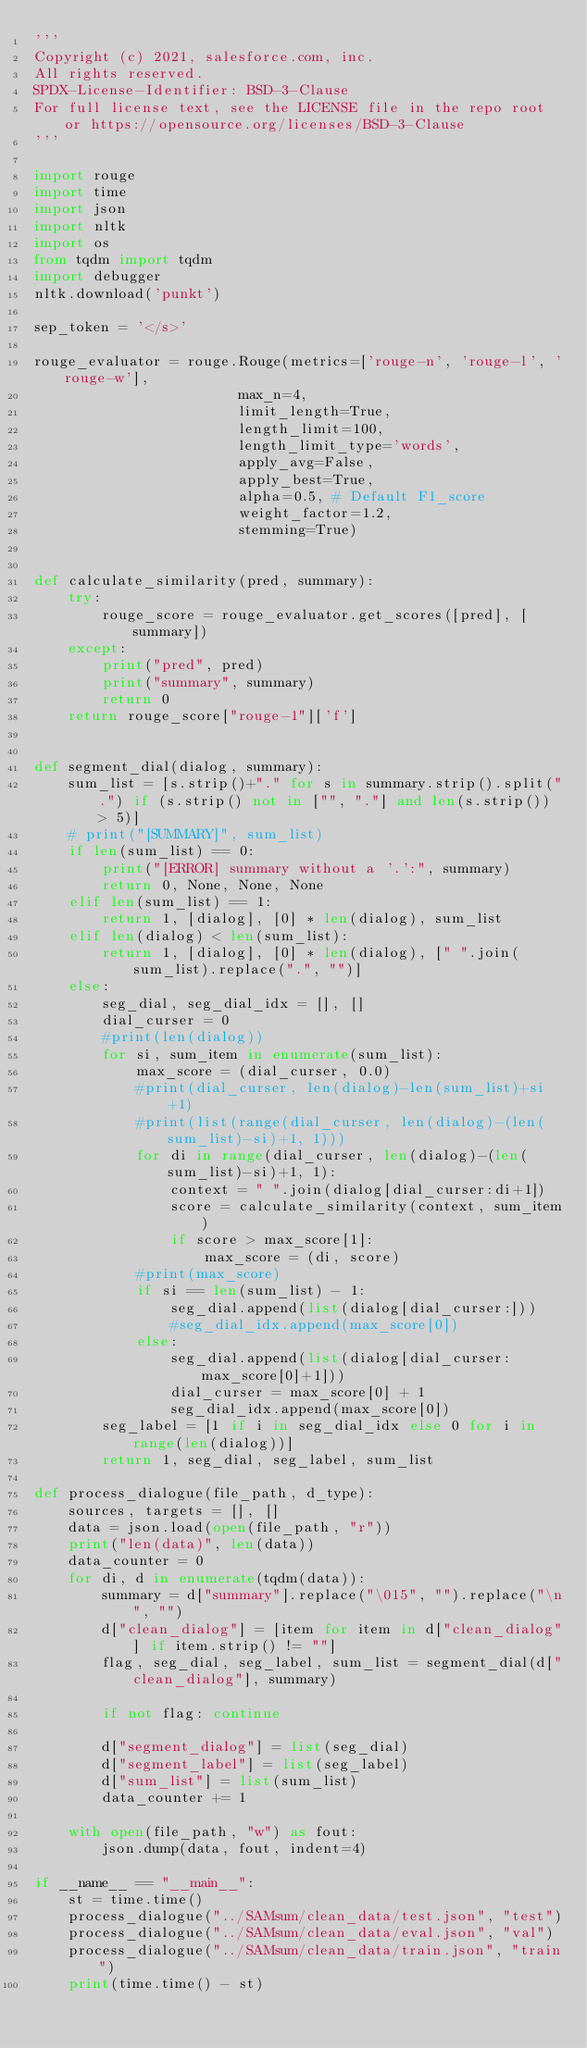<code> <loc_0><loc_0><loc_500><loc_500><_Python_>'''
Copyright (c) 2021, salesforce.com, inc.
All rights reserved.
SPDX-License-Identifier: BSD-3-Clause
For full license text, see the LICENSE file in the repo root or https://opensource.org/licenses/BSD-3-Clause
'''

import rouge
import time
import json
import nltk
import os
from tqdm import tqdm
import debugger
nltk.download('punkt')

sep_token = '</s>'
    
rouge_evaluator = rouge.Rouge(metrics=['rouge-n', 'rouge-l', 'rouge-w'],
                        max_n=4,
                        limit_length=True,
                        length_limit=100,
                        length_limit_type='words',
                        apply_avg=False,
                        apply_best=True,
                        alpha=0.5, # Default F1_score
                        weight_factor=1.2,
                        stemming=True)


def calculate_similarity(pred, summary):
    try:
        rouge_score = rouge_evaluator.get_scores([pred], [summary])
    except:
        print("pred", pred)
        print("summary", summary)
        return 0
    return rouge_score["rouge-1"]['f']


def segment_dial(dialog, summary):
    sum_list = [s.strip()+"." for s in summary.strip().split(".") if (s.strip() not in ["", "."] and len(s.strip()) > 5)]
    # print("[SUMMARY]", sum_list)
    if len(sum_list) == 0:
        print("[ERROR] summary without a '.':", summary)
        return 0, None, None, None
    elif len(sum_list) == 1:
        return 1, [dialog], [0] * len(dialog), sum_list
    elif len(dialog) < len(sum_list):
        return 1, [dialog], [0] * len(dialog), [" ".join(sum_list).replace(".", "")]
    else:
        seg_dial, seg_dial_idx = [], []
        dial_curser = 0
        #print(len(dialog))
        for si, sum_item in enumerate(sum_list):
            max_score = (dial_curser, 0.0) 
            #print(dial_curser, len(dialog)-len(sum_list)+si+1)
            #print(list(range(dial_curser, len(dialog)-(len(sum_list)-si)+1, 1)))
            for di in range(dial_curser, len(dialog)-(len(sum_list)-si)+1, 1):
                context = " ".join(dialog[dial_curser:di+1])
                score = calculate_similarity(context, sum_item)
                if score > max_score[1]:
                    max_score = (di, score)
            #print(max_score)
            if si == len(sum_list) - 1:
                seg_dial.append(list(dialog[dial_curser:]))
                #seg_dial_idx.append(max_score[0])
            else:
                seg_dial.append(list(dialog[dial_curser:max_score[0]+1])) 
                dial_curser = max_score[0] + 1
                seg_dial_idx.append(max_score[0])
        seg_label = [1 if i in seg_dial_idx else 0 for i in range(len(dialog))]
        return 1, seg_dial, seg_label, sum_list

def process_dialogue(file_path, d_type):
    sources, targets = [], []
    data = json.load(open(file_path, "r"))
    print("len(data)", len(data))
    data_counter = 0
    for di, d in enumerate(tqdm(data)):
        summary = d["summary"].replace("\015", "").replace("\n", "")
        d["clean_dialog"] = [item for item in d["clean_dialog"] if item.strip() != ""]
        flag, seg_dial, seg_label, sum_list = segment_dial(d["clean_dialog"], summary)
        
        if not flag: continue
        
        d["segment_dialog"] = list(seg_dial)
        d["segment_label"] = list(seg_label)
        d["sum_list"] = list(sum_list)
        data_counter += 1
        
    with open(file_path, "w") as fout:
        json.dump(data, fout, indent=4)

if __name__ == "__main__":
    st = time.time()
    process_dialogue("../SAMsum/clean_data/test.json", "test")
    process_dialogue("../SAMsum/clean_data/eval.json", "val")
    process_dialogue("../SAMsum/clean_data/train.json", "train")
    print(time.time() - st)
</code> 